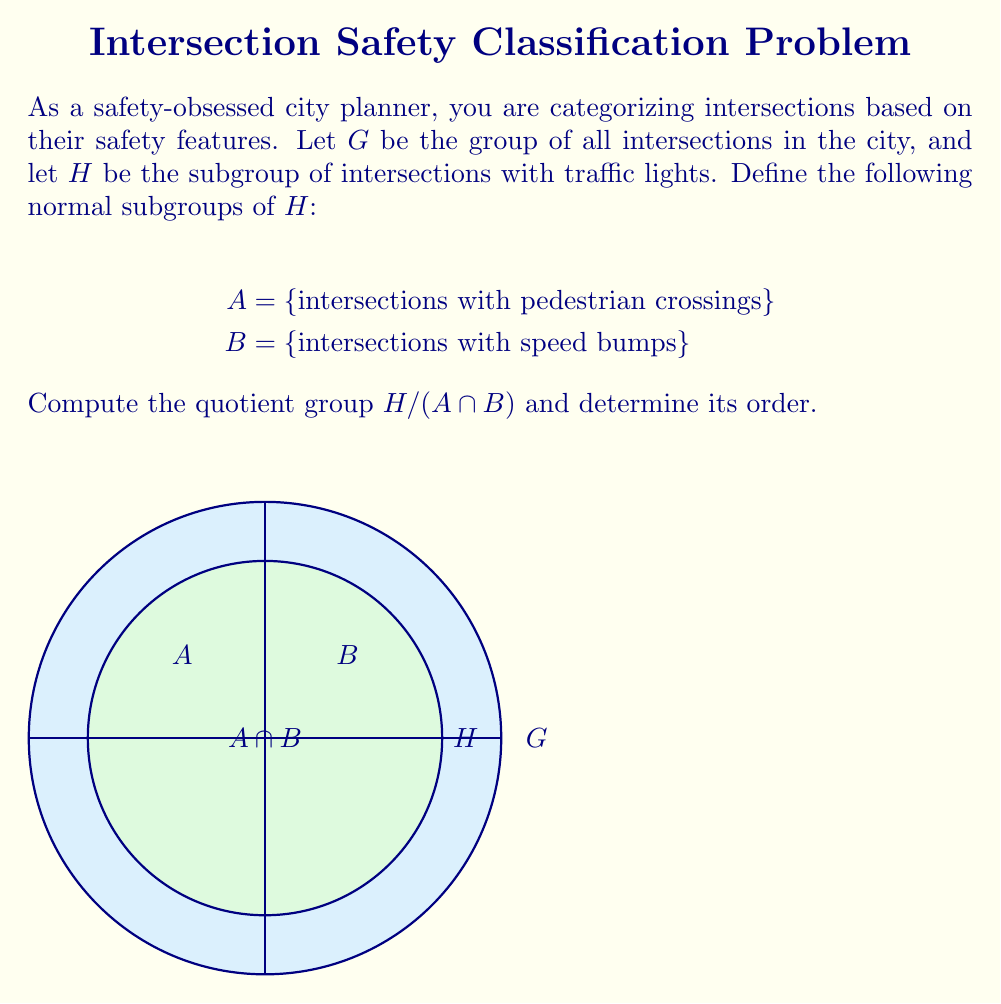Solve this math problem. To solve this problem, we'll follow these steps:

1) First, we need to understand what $A \cap B$ represents. It's the set of intersections that have both pedestrian crossings and speed bumps.

2) The quotient group $H / (A \cap B)$ consists of cosets of $A \cap B$ in $H$. Each coset represents a class of intersections that are equivalent modulo having both pedestrian crossings and speed bumps.

3) To determine the order of $H / (A \cap B)$, we can use the Lagrange's theorem:

   $|H / (A \cap B)| = |H| / |A \cap B|$

4) We don't have specific numbers for $|H|$ and $|A \cap B|$, but we can express the result in terms of these:

   Let $|H| = n$ (total number of intersections with traffic lights)
   Let $|A \cap B| = m$ (number of intersections with both pedestrian crossings and speed bumps)

5) Then, the order of the quotient group is:

   $|H / (A \cap B)| = n / m$

6) The elements of this quotient group can be interpreted as:
   - Intersections with traffic lights, pedestrian crossings, and speed bumps (represented by $A \cap B$)
   - Intersections with traffic lights and pedestrian crossings, but no speed bumps
   - Intersections with traffic lights and speed bumps, but no pedestrian crossings
   - Intersections with only traffic lights, no pedestrian crossings or speed bumps

This grouping allows the city planner to quickly categorize intersections based on their safety features, which is crucial for urban safety planning.
Answer: $H / (A \cap B)$ with order $n/m$ 